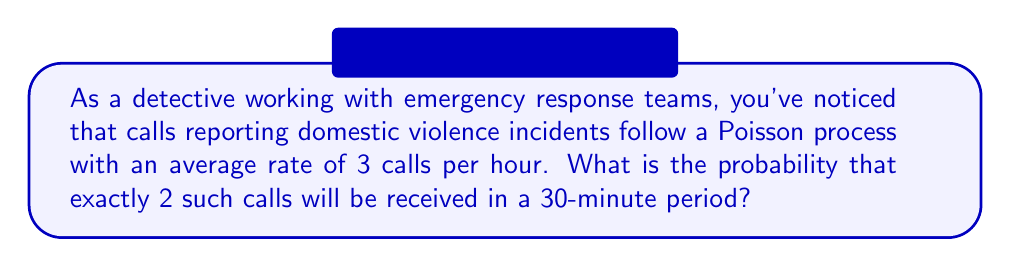Give your solution to this math problem. Let's approach this step-by-step:

1) First, we need to identify the parameters of our Poisson process:
   - The rate (λ) is 3 calls per hour
   - We're interested in a 30-minute period, which is 0.5 hours

2) We need to adjust our rate for the 30-minute period:
   $λ_{30min} = 3 * 0.5 = 1.5$ calls per 30 minutes

3) The probability of exactly k events in a Poisson process is given by the formula:

   $P(X = k) = \frac{e^{-λ}λ^k}{k!}$

   Where:
   - e is Euler's number (approximately 2.71828)
   - λ is the average rate for the time period
   - k is the number of events we're interested in

4) In this case:
   - λ = 1.5
   - k = 2

5) Let's substitute these values into our formula:

   $P(X = 2) = \frac{e^{-1.5}1.5^2}{2!}$

6) Now let's calculate:
   
   $P(X = 2) = \frac{e^{-1.5} * 2.25}{2}$

7) Using a calculator:
   
   $P(X = 2) ≈ 0.2528$

8) We can express this as a percentage: 25.28%

Therefore, the probability of receiving exactly 2 domestic violence calls in a 30-minute period is approximately 25.28%.
Answer: 25.28% 